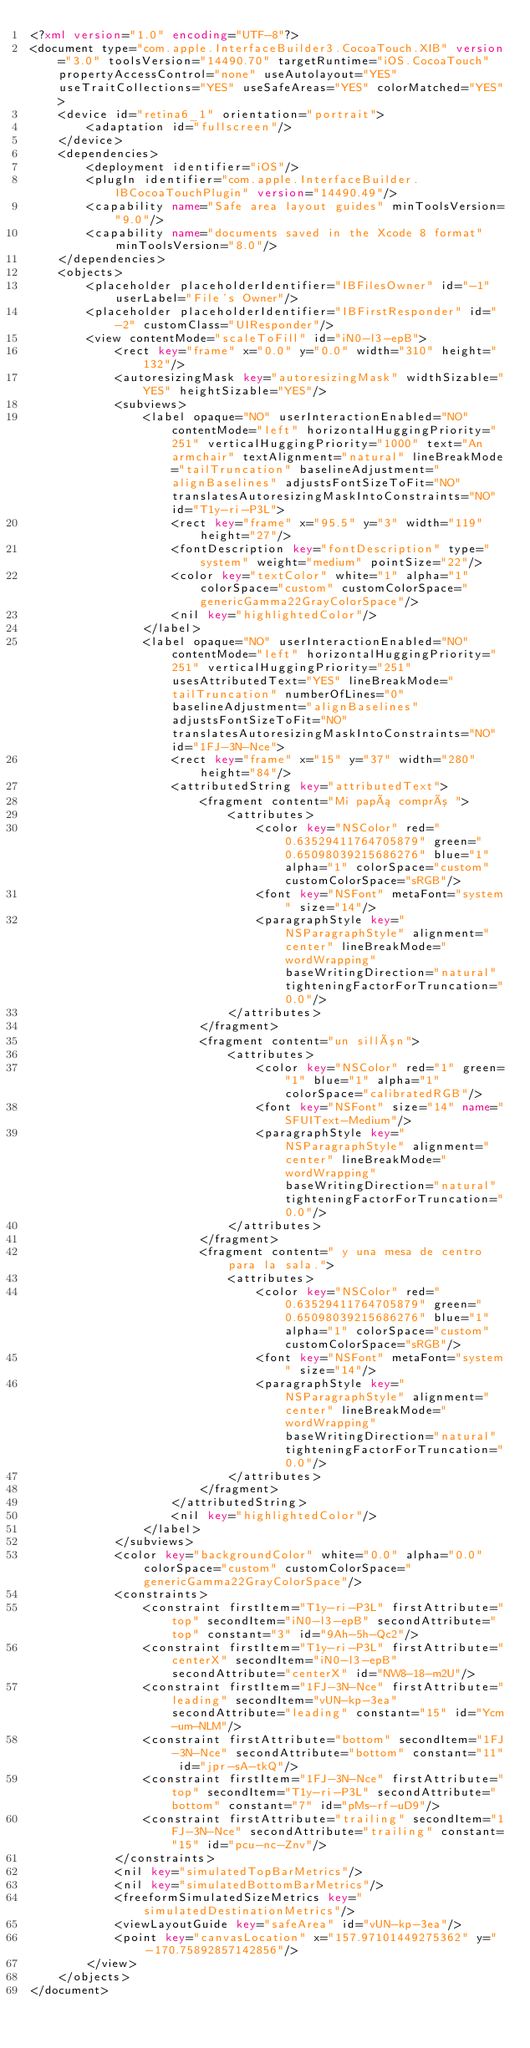Convert code to text. <code><loc_0><loc_0><loc_500><loc_500><_XML_><?xml version="1.0" encoding="UTF-8"?>
<document type="com.apple.InterfaceBuilder3.CocoaTouch.XIB" version="3.0" toolsVersion="14490.70" targetRuntime="iOS.CocoaTouch" propertyAccessControl="none" useAutolayout="YES" useTraitCollections="YES" useSafeAreas="YES" colorMatched="YES">
    <device id="retina6_1" orientation="portrait">
        <adaptation id="fullscreen"/>
    </device>
    <dependencies>
        <deployment identifier="iOS"/>
        <plugIn identifier="com.apple.InterfaceBuilder.IBCocoaTouchPlugin" version="14490.49"/>
        <capability name="Safe area layout guides" minToolsVersion="9.0"/>
        <capability name="documents saved in the Xcode 8 format" minToolsVersion="8.0"/>
    </dependencies>
    <objects>
        <placeholder placeholderIdentifier="IBFilesOwner" id="-1" userLabel="File's Owner"/>
        <placeholder placeholderIdentifier="IBFirstResponder" id="-2" customClass="UIResponder"/>
        <view contentMode="scaleToFill" id="iN0-l3-epB">
            <rect key="frame" x="0.0" y="0.0" width="310" height="132"/>
            <autoresizingMask key="autoresizingMask" widthSizable="YES" heightSizable="YES"/>
            <subviews>
                <label opaque="NO" userInteractionEnabled="NO" contentMode="left" horizontalHuggingPriority="251" verticalHuggingPriority="1000" text="An armchair" textAlignment="natural" lineBreakMode="tailTruncation" baselineAdjustment="alignBaselines" adjustsFontSizeToFit="NO" translatesAutoresizingMaskIntoConstraints="NO" id="T1y-ri-P3L">
                    <rect key="frame" x="95.5" y="3" width="119" height="27"/>
                    <fontDescription key="fontDescription" type="system" weight="medium" pointSize="22"/>
                    <color key="textColor" white="1" alpha="1" colorSpace="custom" customColorSpace="genericGamma22GrayColorSpace"/>
                    <nil key="highlightedColor"/>
                </label>
                <label opaque="NO" userInteractionEnabled="NO" contentMode="left" horizontalHuggingPriority="251" verticalHuggingPriority="251" usesAttributedText="YES" lineBreakMode="tailTruncation" numberOfLines="0" baselineAdjustment="alignBaselines" adjustsFontSizeToFit="NO" translatesAutoresizingMaskIntoConstraints="NO" id="1FJ-3N-Nce">
                    <rect key="frame" x="15" y="37" width="280" height="84"/>
                    <attributedString key="attributedText">
                        <fragment content="Mi papá compró ">
                            <attributes>
                                <color key="NSColor" red="0.63529411764705879" green="0.65098039215686276" blue="1" alpha="1" colorSpace="custom" customColorSpace="sRGB"/>
                                <font key="NSFont" metaFont="system" size="14"/>
                                <paragraphStyle key="NSParagraphStyle" alignment="center" lineBreakMode="wordWrapping" baseWritingDirection="natural" tighteningFactorForTruncation="0.0"/>
                            </attributes>
                        </fragment>
                        <fragment content="un sillón">
                            <attributes>
                                <color key="NSColor" red="1" green="1" blue="1" alpha="1" colorSpace="calibratedRGB"/>
                                <font key="NSFont" size="14" name="SFUIText-Medium"/>
                                <paragraphStyle key="NSParagraphStyle" alignment="center" lineBreakMode="wordWrapping" baseWritingDirection="natural" tighteningFactorForTruncation="0.0"/>
                            </attributes>
                        </fragment>
                        <fragment content=" y una mesa de centro para la sala.">
                            <attributes>
                                <color key="NSColor" red="0.63529411764705879" green="0.65098039215686276" blue="1" alpha="1" colorSpace="custom" customColorSpace="sRGB"/>
                                <font key="NSFont" metaFont="system" size="14"/>
                                <paragraphStyle key="NSParagraphStyle" alignment="center" lineBreakMode="wordWrapping" baseWritingDirection="natural" tighteningFactorForTruncation="0.0"/>
                            </attributes>
                        </fragment>
                    </attributedString>
                    <nil key="highlightedColor"/>
                </label>
            </subviews>
            <color key="backgroundColor" white="0.0" alpha="0.0" colorSpace="custom" customColorSpace="genericGamma22GrayColorSpace"/>
            <constraints>
                <constraint firstItem="T1y-ri-P3L" firstAttribute="top" secondItem="iN0-l3-epB" secondAttribute="top" constant="3" id="9Ah-5h-Qc2"/>
                <constraint firstItem="T1y-ri-P3L" firstAttribute="centerX" secondItem="iN0-l3-epB" secondAttribute="centerX" id="NW8-18-m2U"/>
                <constraint firstItem="1FJ-3N-Nce" firstAttribute="leading" secondItem="vUN-kp-3ea" secondAttribute="leading" constant="15" id="Ycm-um-NLM"/>
                <constraint firstAttribute="bottom" secondItem="1FJ-3N-Nce" secondAttribute="bottom" constant="11" id="jpr-sA-tkQ"/>
                <constraint firstItem="1FJ-3N-Nce" firstAttribute="top" secondItem="T1y-ri-P3L" secondAttribute="bottom" constant="7" id="pMs-rf-uD9"/>
                <constraint firstAttribute="trailing" secondItem="1FJ-3N-Nce" secondAttribute="trailing" constant="15" id="pcu-nc-Znv"/>
            </constraints>
            <nil key="simulatedTopBarMetrics"/>
            <nil key="simulatedBottomBarMetrics"/>
            <freeformSimulatedSizeMetrics key="simulatedDestinationMetrics"/>
            <viewLayoutGuide key="safeArea" id="vUN-kp-3ea"/>
            <point key="canvasLocation" x="157.97101449275362" y="-170.75892857142856"/>
        </view>
    </objects>
</document>
</code> 